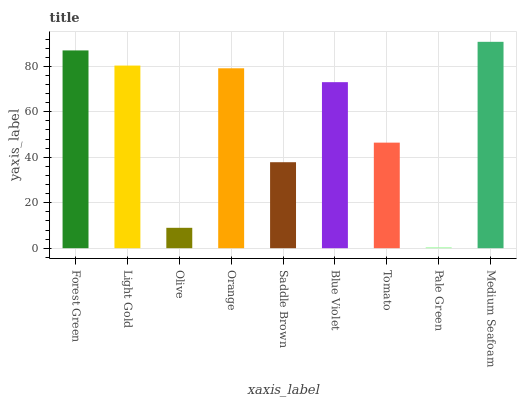Is Pale Green the minimum?
Answer yes or no. Yes. Is Medium Seafoam the maximum?
Answer yes or no. Yes. Is Light Gold the minimum?
Answer yes or no. No. Is Light Gold the maximum?
Answer yes or no. No. Is Forest Green greater than Light Gold?
Answer yes or no. Yes. Is Light Gold less than Forest Green?
Answer yes or no. Yes. Is Light Gold greater than Forest Green?
Answer yes or no. No. Is Forest Green less than Light Gold?
Answer yes or no. No. Is Blue Violet the high median?
Answer yes or no. Yes. Is Blue Violet the low median?
Answer yes or no. Yes. Is Light Gold the high median?
Answer yes or no. No. Is Light Gold the low median?
Answer yes or no. No. 